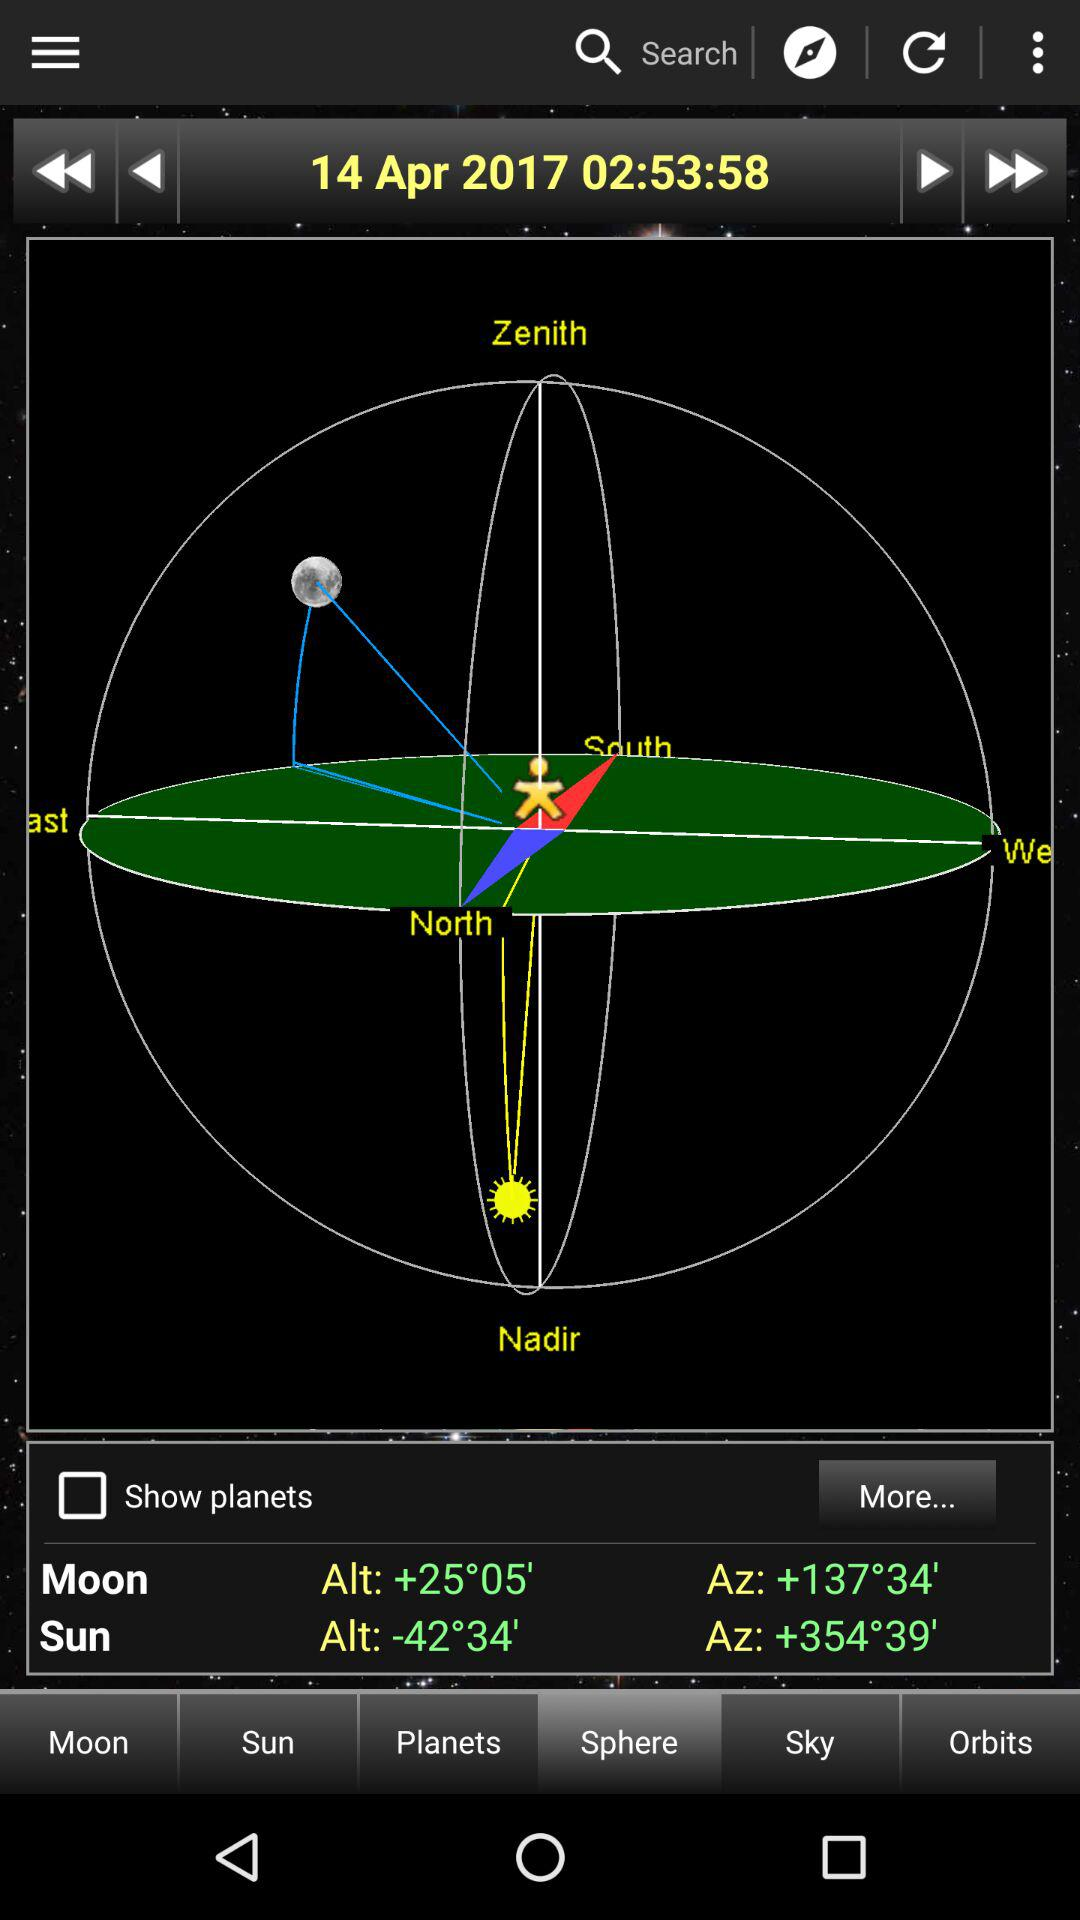Which tab is selected? The selected tab is "Sphere". 